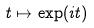<formula> <loc_0><loc_0><loc_500><loc_500>t \mapsto \exp ( i t )</formula> 